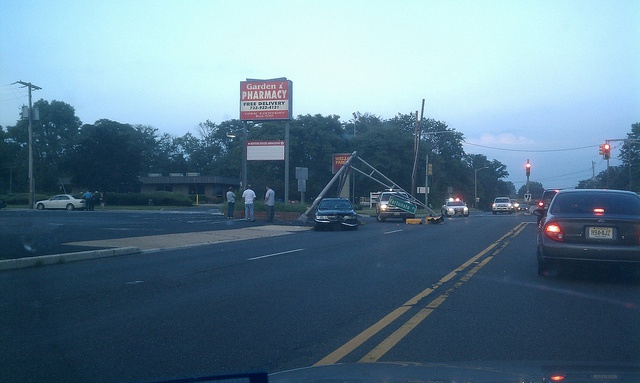Describe the objects in this image and their specific colors. I can see car in lightblue, navy, darkblue, black, and gray tones, car in lightblue, blue, navy, black, and gray tones, car in lightblue, gray, navy, blue, and black tones, car in lightblue, gray, blue, and navy tones, and people in lightblue, blue, navy, gray, and darkgray tones in this image. 